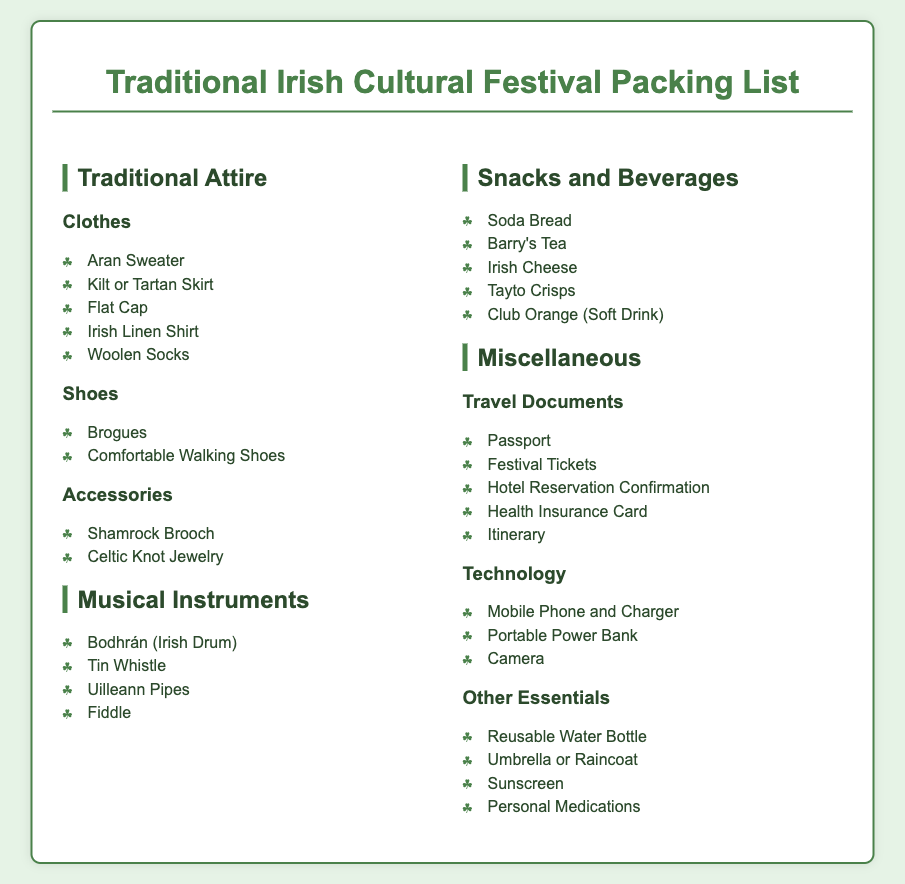what clothing items are recommended for traditional attire? The clothing items listed under Traditional Attire include Aran Sweater, Kilt or Tartan Skirt, Flat Cap, Irish Linen Shirt, and Woolen Socks.
Answer: Aran Sweater, Kilt or Tartan Skirt, Flat Cap, Irish Linen Shirt, Woolen Socks how many musical instruments are listed? The document specifies four types of musical instruments under the Musical Instruments section.
Answer: Four which tea brand is suggested in snacks and beverages? The document includes Barry's Tea as a snack option under Snacks and Beverages.
Answer: Barry's Tea what travel document is required for the festival? The document lists several travel documents including Passport, Festival Tickets, Hotel Reservation Confirmation, Health Insurance Card, and Itinerary; Passport is a key travel document.
Answer: Passport what type of shoes are recommended for comfort? The document suggests Comfortable Walking Shoes under the Shoes section for comfort.
Answer: Comfortable Walking Shoes which item protects against rain? The document includes Umbrella or Raincoat in the Other Essentials section for protection against rain.
Answer: Umbrella or Raincoat what musical instrument is used as a drum? The Bodhrán, listed under Musical Instruments, is used as an Irish drum.
Answer: Bodhrán how many items are listed under Other Essentials? The document lists four items under Other Essentials.
Answer: Four 